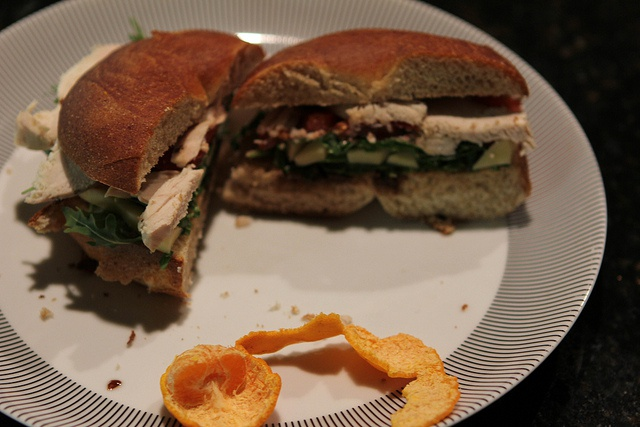Describe the objects in this image and their specific colors. I can see dining table in black, maroon, tan, and gray tones, sandwich in black, maroon, and brown tones, orange in black, brown, and orange tones, orange in black, brown, red, and tan tones, and orange in black, brown, red, and orange tones in this image. 